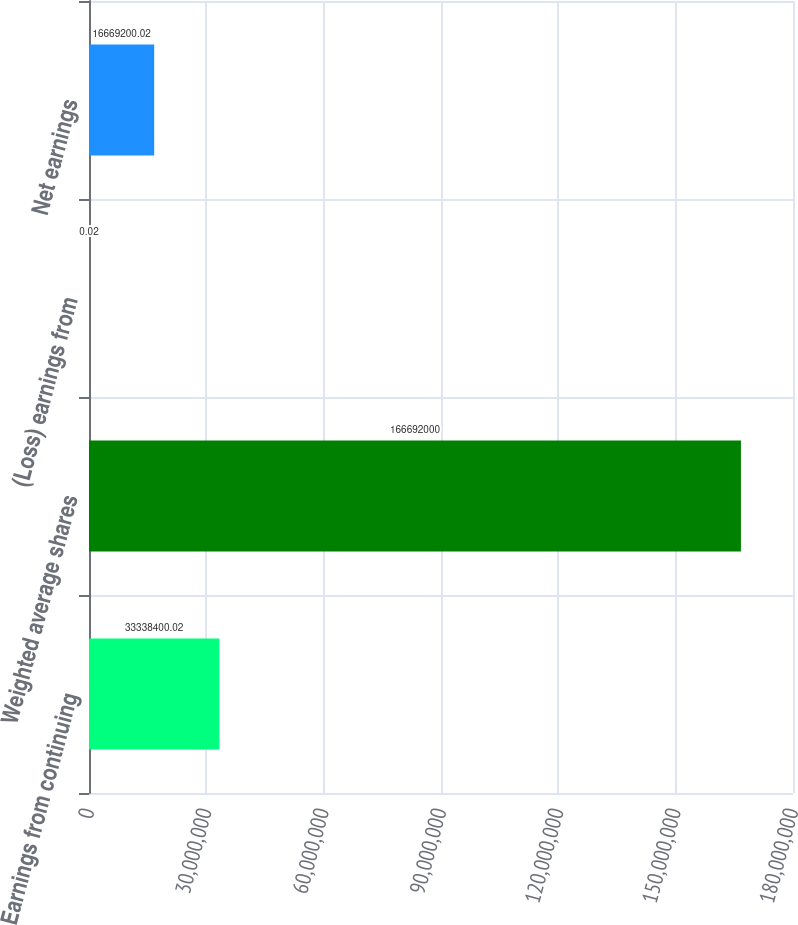Convert chart to OTSL. <chart><loc_0><loc_0><loc_500><loc_500><bar_chart><fcel>Earnings from continuing<fcel>Weighted average shares<fcel>(Loss) earnings from<fcel>Net earnings<nl><fcel>3.33384e+07<fcel>1.66692e+08<fcel>0.02<fcel>1.66692e+07<nl></chart> 